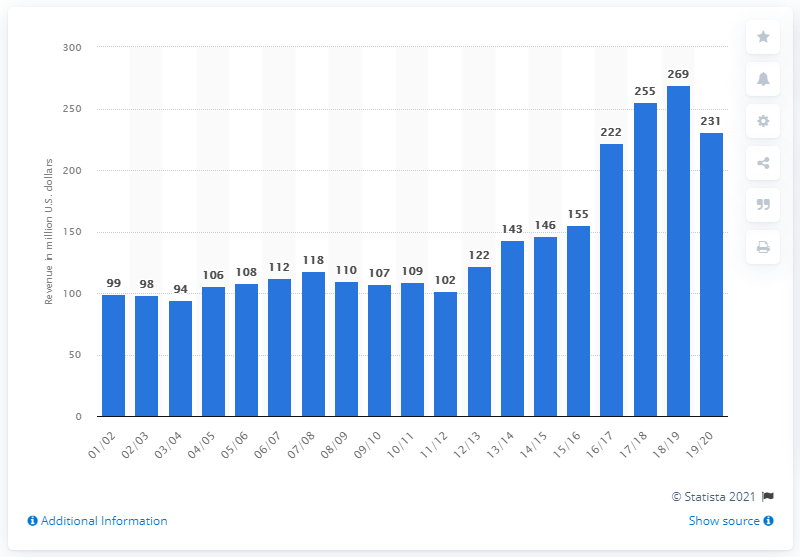Identify some key points in this picture. In the 2019/2020 season, the Washington Wizards generated an estimated revenue of 231 million dollars. 